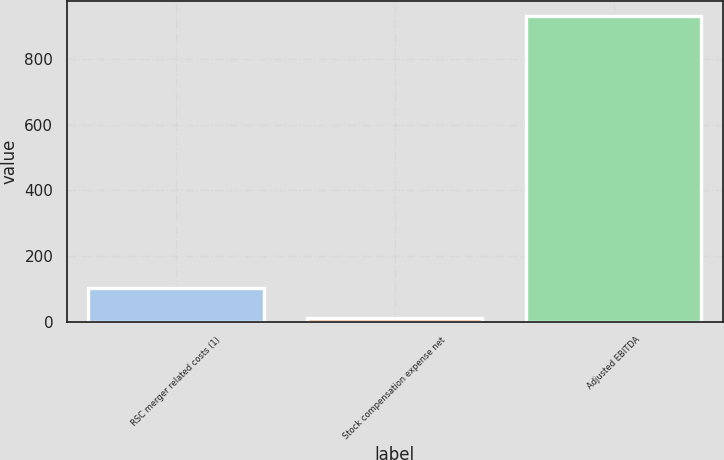Convert chart to OTSL. <chart><loc_0><loc_0><loc_500><loc_500><bar_chart><fcel>RSC merger related costs (1)<fcel>Stock compensation expense net<fcel>Adjusted EBITDA<nl><fcel>103.7<fcel>12<fcel>929<nl></chart> 